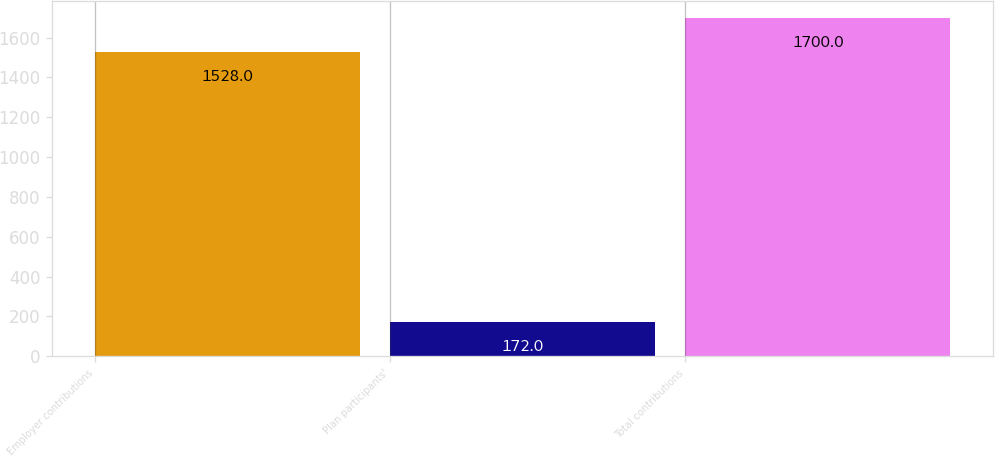Convert chart to OTSL. <chart><loc_0><loc_0><loc_500><loc_500><bar_chart><fcel>Employer contributions<fcel>Plan participants'<fcel>Total contributions<nl><fcel>1528<fcel>172<fcel>1700<nl></chart> 